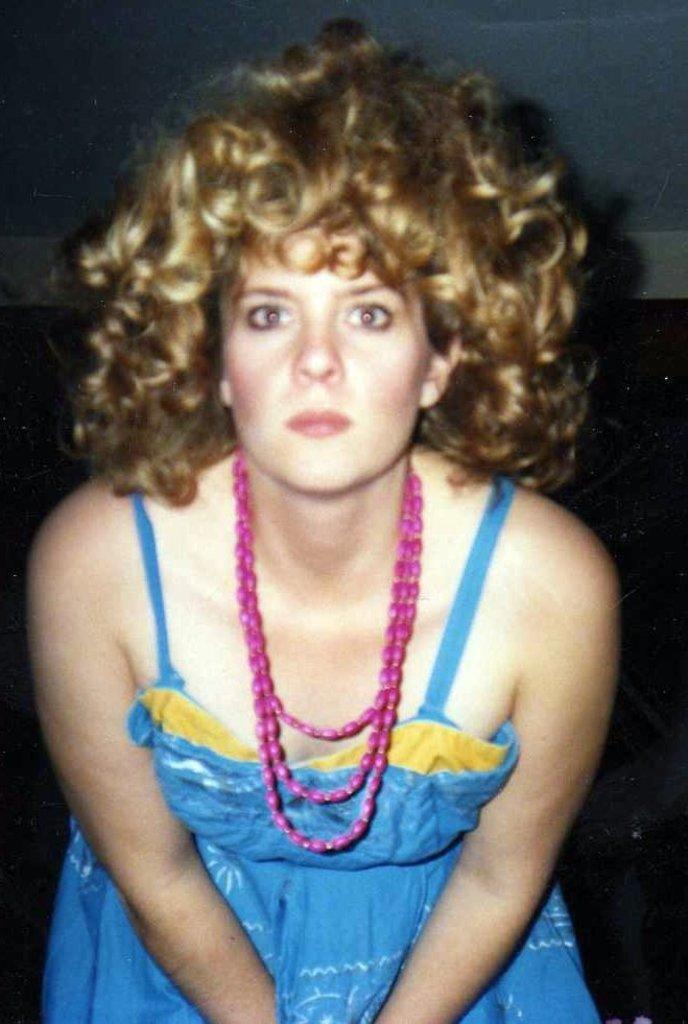How would you summarize this image in a sentence or two? In this image in the center there is one woman who is wearing some necklace, and in the background there is wall. 